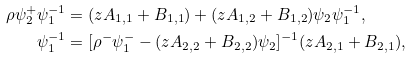Convert formula to latex. <formula><loc_0><loc_0><loc_500><loc_500>\rho \psi ^ { + } _ { 2 } \psi ^ { - 1 } _ { 1 } & = ( z A _ { 1 , 1 } + B _ { 1 , 1 } ) + ( z A _ { 1 , 2 } + B _ { 1 , 2 } ) \psi _ { 2 } \psi ^ { - 1 } _ { 1 } , \\ \psi ^ { - 1 } _ { 1 } & = [ \rho ^ { - } \psi ^ { - } _ { 1 } - ( z A _ { 2 , 2 } + B _ { 2 , 2 } ) \psi _ { 2 } ] ^ { - 1 } ( z A _ { 2 , 1 } + B _ { 2 , 1 } ) ,</formula> 